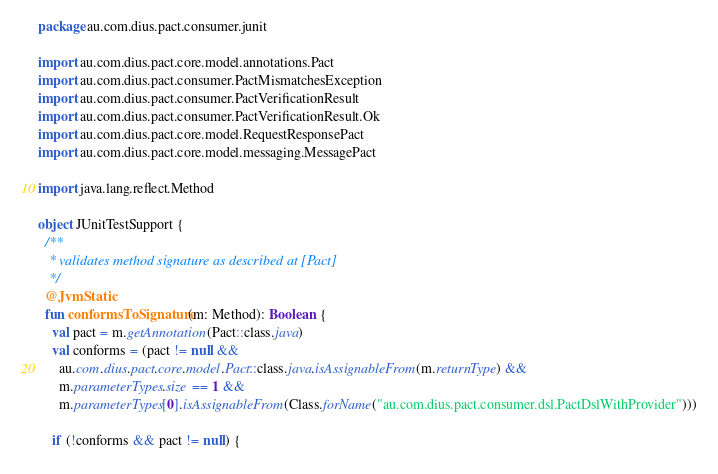<code> <loc_0><loc_0><loc_500><loc_500><_Kotlin_>package au.com.dius.pact.consumer.junit

import au.com.dius.pact.core.model.annotations.Pact
import au.com.dius.pact.consumer.PactMismatchesException
import au.com.dius.pact.consumer.PactVerificationResult
import au.com.dius.pact.consumer.PactVerificationResult.Ok
import au.com.dius.pact.core.model.RequestResponsePact
import au.com.dius.pact.core.model.messaging.MessagePact

import java.lang.reflect.Method

object JUnitTestSupport {
  /**
   * validates method signature as described at [Pact]
   */
  @JvmStatic
  fun conformsToSignature(m: Method): Boolean {
    val pact = m.getAnnotation(Pact::class.java)
    val conforms = (pact != null &&
      au.com.dius.pact.core.model.Pact::class.java.isAssignableFrom(m.returnType) &&
      m.parameterTypes.size == 1 &&
      m.parameterTypes[0].isAssignableFrom(Class.forName("au.com.dius.pact.consumer.dsl.PactDslWithProvider")))

    if (!conforms && pact != null) {</code> 